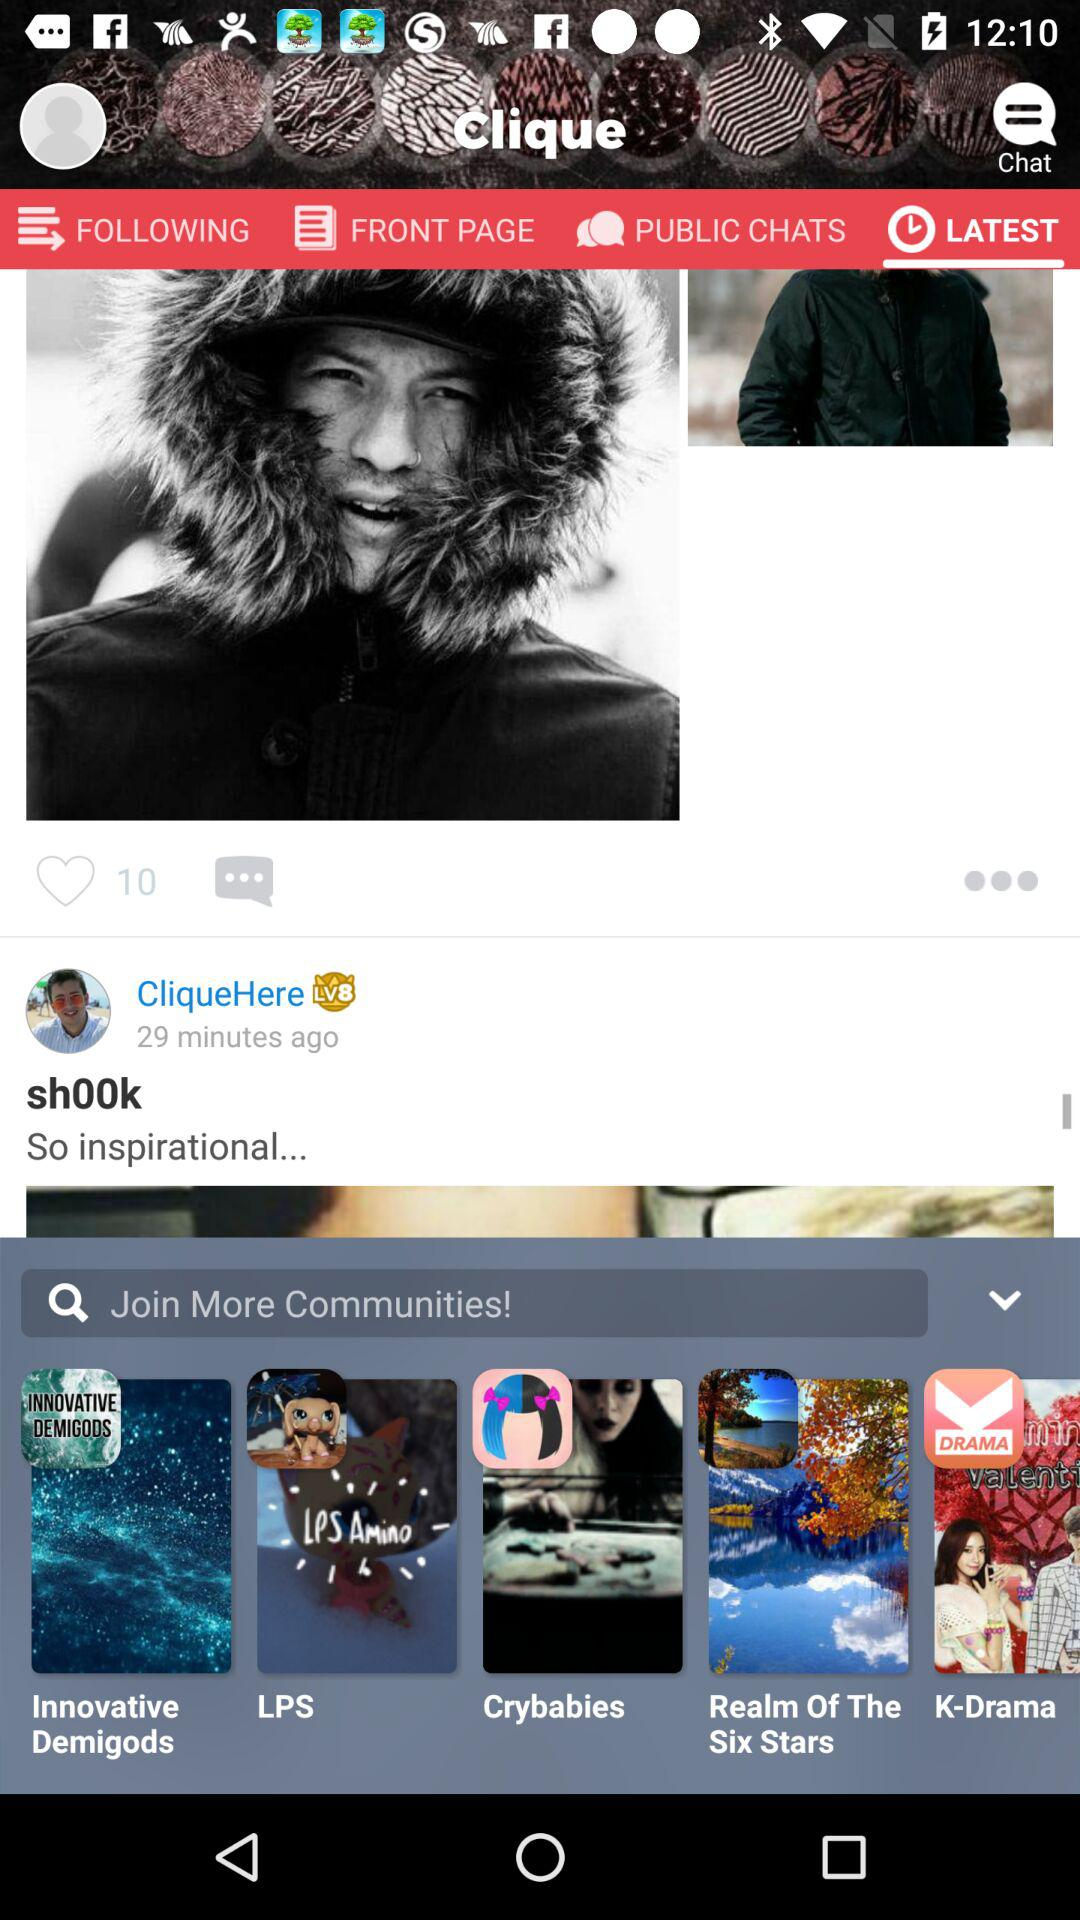Which tab is selected? The selected tab is "LATEST". 